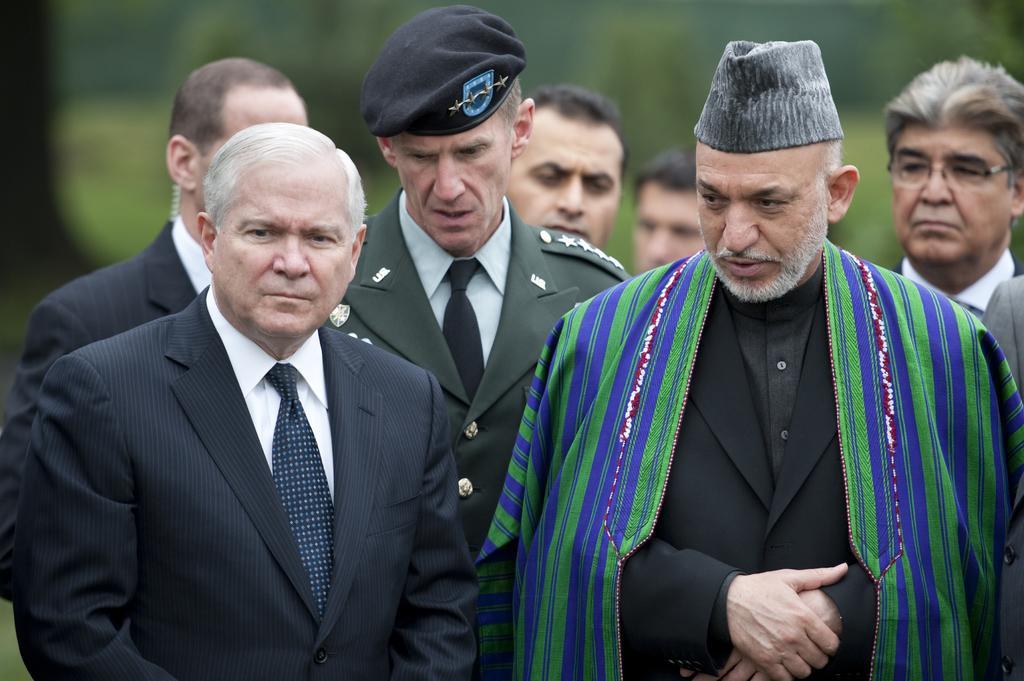Please provide a concise description of this image. In the front of the image there are people. Among them two people wore caps and one person wore a shawl. In the background of the image is blurred.   